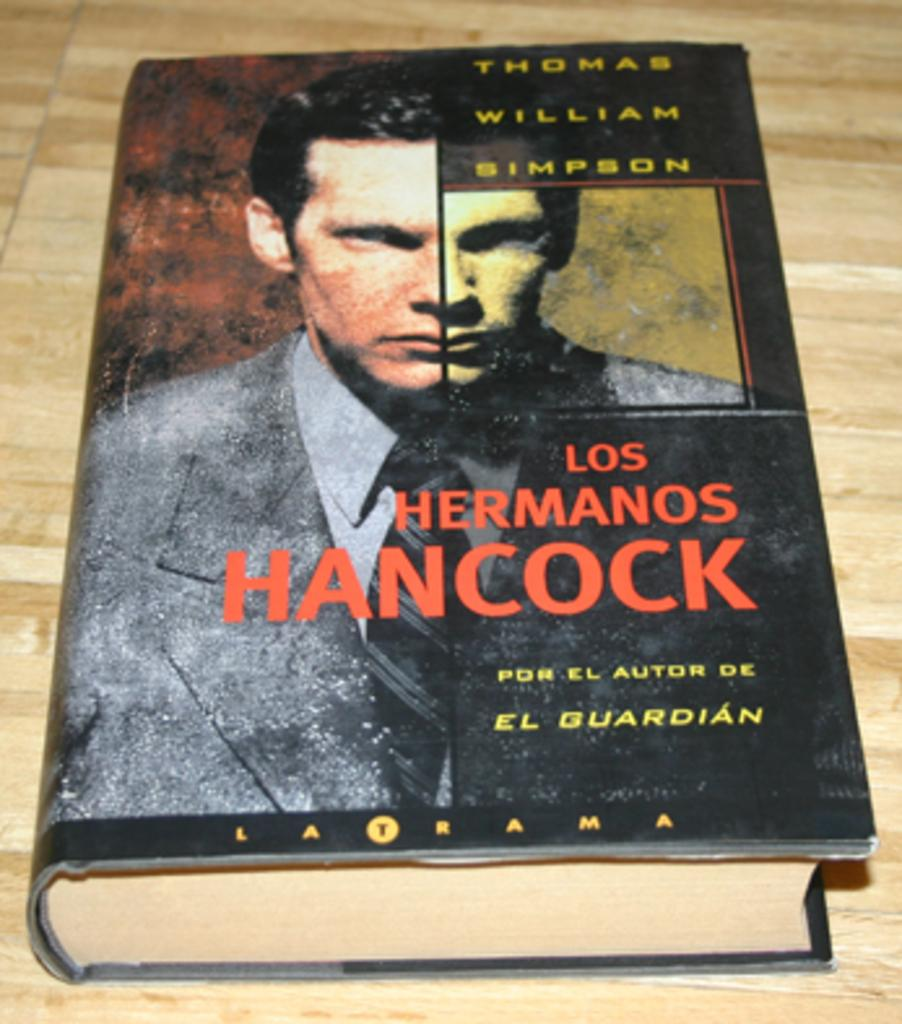<image>
Write a terse but informative summary of the picture. a copy of the book los hermanos hancock written by thomas william simpson. 